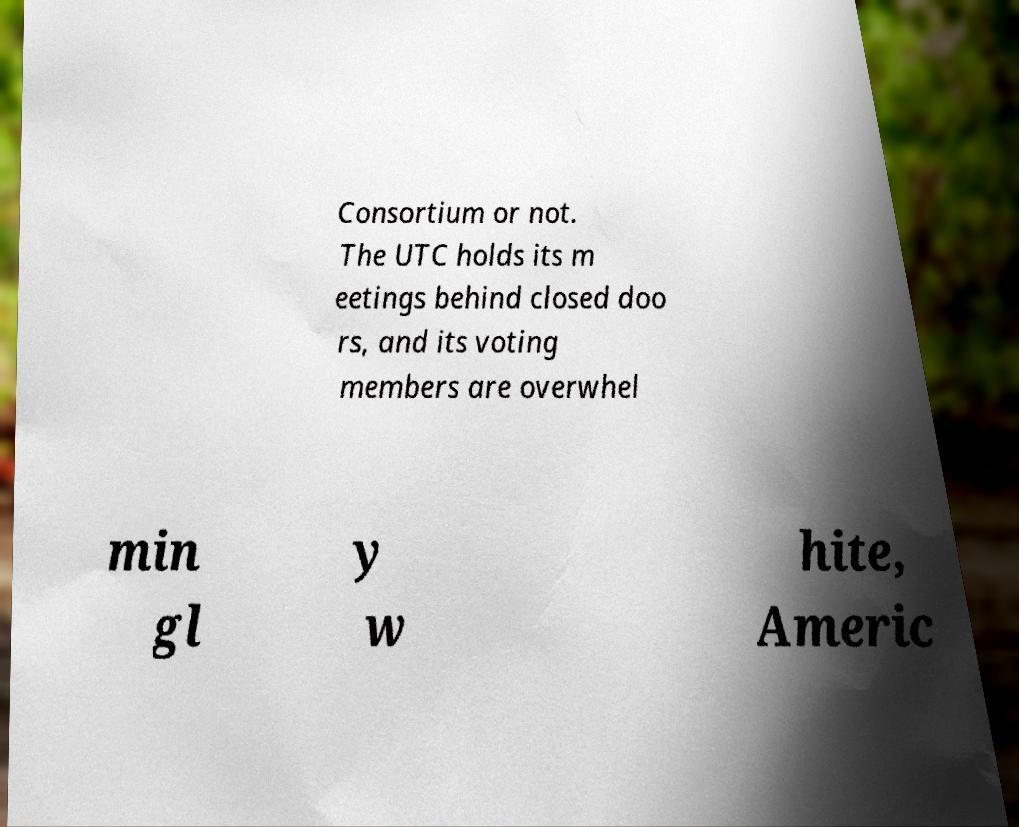Could you extract and type out the text from this image? Consortium or not. The UTC holds its m eetings behind closed doo rs, and its voting members are overwhel min gl y w hite, Americ 